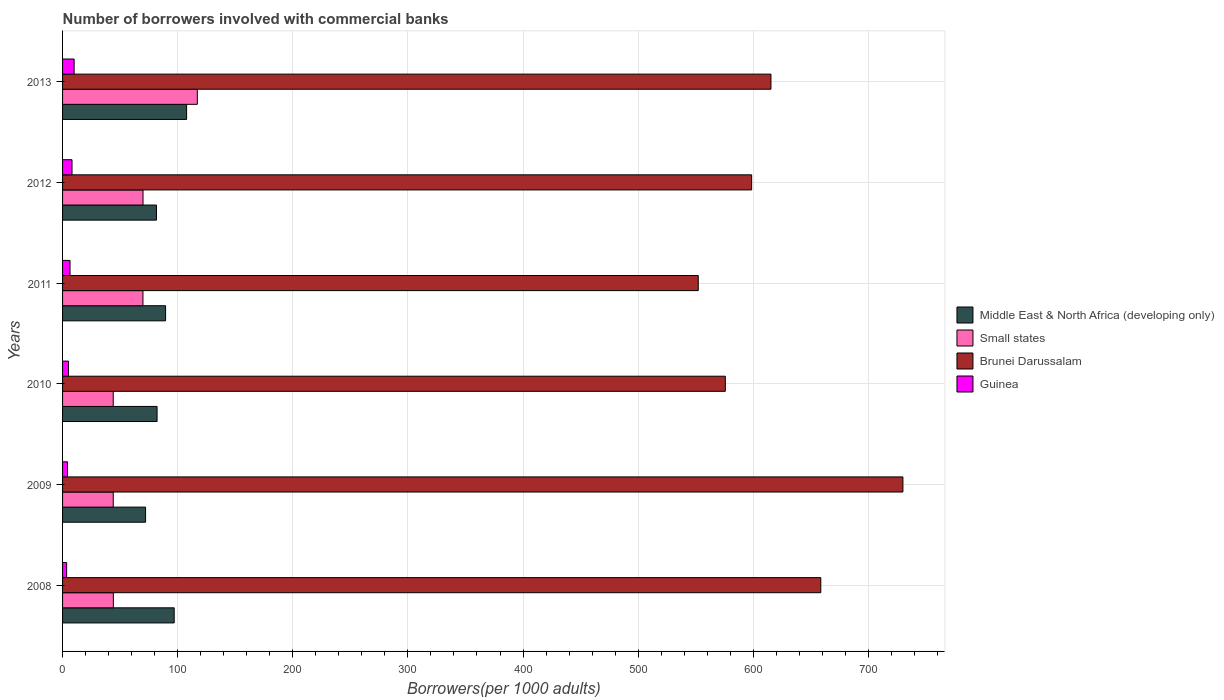How many different coloured bars are there?
Your answer should be compact. 4. How many bars are there on the 3rd tick from the top?
Your answer should be compact. 4. How many bars are there on the 6th tick from the bottom?
Ensure brevity in your answer.  4. What is the label of the 5th group of bars from the top?
Ensure brevity in your answer.  2009. In how many cases, is the number of bars for a given year not equal to the number of legend labels?
Keep it short and to the point. 0. What is the number of borrowers involved with commercial banks in Guinea in 2011?
Make the answer very short. 6.48. Across all years, what is the maximum number of borrowers involved with commercial banks in Middle East & North Africa (developing only)?
Your response must be concise. 107.75. Across all years, what is the minimum number of borrowers involved with commercial banks in Small states?
Offer a terse response. 44. In which year was the number of borrowers involved with commercial banks in Middle East & North Africa (developing only) minimum?
Your response must be concise. 2009. What is the total number of borrowers involved with commercial banks in Guinea in the graph?
Keep it short and to the point. 37.73. What is the difference between the number of borrowers involved with commercial banks in Guinea in 2008 and that in 2013?
Give a very brief answer. -6.51. What is the difference between the number of borrowers involved with commercial banks in Brunei Darussalam in 2008 and the number of borrowers involved with commercial banks in Middle East & North Africa (developing only) in 2013?
Offer a very short reply. 550.92. What is the average number of borrowers involved with commercial banks in Brunei Darussalam per year?
Give a very brief answer. 621.77. In the year 2010, what is the difference between the number of borrowers involved with commercial banks in Brunei Darussalam and number of borrowers involved with commercial banks in Small states?
Make the answer very short. 531.73. What is the ratio of the number of borrowers involved with commercial banks in Middle East & North Africa (developing only) in 2010 to that in 2013?
Your answer should be compact. 0.76. Is the difference between the number of borrowers involved with commercial banks in Brunei Darussalam in 2008 and 2011 greater than the difference between the number of borrowers involved with commercial banks in Small states in 2008 and 2011?
Provide a short and direct response. Yes. What is the difference between the highest and the second highest number of borrowers involved with commercial banks in Small states?
Provide a succinct answer. 47.18. What is the difference between the highest and the lowest number of borrowers involved with commercial banks in Brunei Darussalam?
Your response must be concise. 177.78. Is the sum of the number of borrowers involved with commercial banks in Middle East & North Africa (developing only) in 2012 and 2013 greater than the maximum number of borrowers involved with commercial banks in Small states across all years?
Provide a short and direct response. Yes. Is it the case that in every year, the sum of the number of borrowers involved with commercial banks in Small states and number of borrowers involved with commercial banks in Brunei Darussalam is greater than the sum of number of borrowers involved with commercial banks in Middle East & North Africa (developing only) and number of borrowers involved with commercial banks in Guinea?
Keep it short and to the point. Yes. What does the 1st bar from the top in 2009 represents?
Offer a very short reply. Guinea. What does the 4th bar from the bottom in 2010 represents?
Provide a succinct answer. Guinea. Are all the bars in the graph horizontal?
Provide a short and direct response. Yes. Are the values on the major ticks of X-axis written in scientific E-notation?
Provide a succinct answer. No. How many legend labels are there?
Offer a terse response. 4. What is the title of the graph?
Make the answer very short. Number of borrowers involved with commercial banks. Does "Sub-Saharan Africa (all income levels)" appear as one of the legend labels in the graph?
Give a very brief answer. No. What is the label or title of the X-axis?
Ensure brevity in your answer.  Borrowers(per 1000 adults). What is the label or title of the Y-axis?
Give a very brief answer. Years. What is the Borrowers(per 1000 adults) in Middle East & North Africa (developing only) in 2008?
Offer a very short reply. 96.96. What is the Borrowers(per 1000 adults) of Small states in 2008?
Give a very brief answer. 44.11. What is the Borrowers(per 1000 adults) in Brunei Darussalam in 2008?
Give a very brief answer. 658.67. What is the Borrowers(per 1000 adults) in Guinea in 2008?
Provide a succinct answer. 3.54. What is the Borrowers(per 1000 adults) of Middle East & North Africa (developing only) in 2009?
Your answer should be compact. 72.11. What is the Borrowers(per 1000 adults) in Small states in 2009?
Give a very brief answer. 44.03. What is the Borrowers(per 1000 adults) of Brunei Darussalam in 2009?
Provide a succinct answer. 730.02. What is the Borrowers(per 1000 adults) in Guinea in 2009?
Your response must be concise. 4.3. What is the Borrowers(per 1000 adults) in Middle East & North Africa (developing only) in 2010?
Your answer should be compact. 82.1. What is the Borrowers(per 1000 adults) of Small states in 2010?
Provide a short and direct response. 44. What is the Borrowers(per 1000 adults) in Brunei Darussalam in 2010?
Offer a terse response. 575.73. What is the Borrowers(per 1000 adults) of Guinea in 2010?
Your answer should be compact. 5.16. What is the Borrowers(per 1000 adults) of Middle East & North Africa (developing only) in 2011?
Offer a very short reply. 89.5. What is the Borrowers(per 1000 adults) of Small states in 2011?
Make the answer very short. 69.83. What is the Borrowers(per 1000 adults) in Brunei Darussalam in 2011?
Make the answer very short. 552.23. What is the Borrowers(per 1000 adults) in Guinea in 2011?
Offer a very short reply. 6.48. What is the Borrowers(per 1000 adults) of Middle East & North Africa (developing only) in 2012?
Your answer should be very brief. 81.61. What is the Borrowers(per 1000 adults) of Small states in 2012?
Your answer should be compact. 69.88. What is the Borrowers(per 1000 adults) of Brunei Darussalam in 2012?
Your answer should be very brief. 598.59. What is the Borrowers(per 1000 adults) in Guinea in 2012?
Offer a very short reply. 8.2. What is the Borrowers(per 1000 adults) of Middle East & North Africa (developing only) in 2013?
Offer a very short reply. 107.75. What is the Borrowers(per 1000 adults) of Small states in 2013?
Offer a very short reply. 117.06. What is the Borrowers(per 1000 adults) of Brunei Darussalam in 2013?
Your response must be concise. 615.37. What is the Borrowers(per 1000 adults) in Guinea in 2013?
Offer a very short reply. 10.05. Across all years, what is the maximum Borrowers(per 1000 adults) in Middle East & North Africa (developing only)?
Ensure brevity in your answer.  107.75. Across all years, what is the maximum Borrowers(per 1000 adults) of Small states?
Give a very brief answer. 117.06. Across all years, what is the maximum Borrowers(per 1000 adults) of Brunei Darussalam?
Provide a short and direct response. 730.02. Across all years, what is the maximum Borrowers(per 1000 adults) in Guinea?
Your response must be concise. 10.05. Across all years, what is the minimum Borrowers(per 1000 adults) in Middle East & North Africa (developing only)?
Give a very brief answer. 72.11. Across all years, what is the minimum Borrowers(per 1000 adults) of Small states?
Your response must be concise. 44. Across all years, what is the minimum Borrowers(per 1000 adults) in Brunei Darussalam?
Make the answer very short. 552.23. Across all years, what is the minimum Borrowers(per 1000 adults) of Guinea?
Offer a terse response. 3.54. What is the total Borrowers(per 1000 adults) in Middle East & North Africa (developing only) in the graph?
Offer a very short reply. 530.03. What is the total Borrowers(per 1000 adults) in Small states in the graph?
Make the answer very short. 388.91. What is the total Borrowers(per 1000 adults) in Brunei Darussalam in the graph?
Offer a very short reply. 3730.61. What is the total Borrowers(per 1000 adults) in Guinea in the graph?
Ensure brevity in your answer.  37.73. What is the difference between the Borrowers(per 1000 adults) in Middle East & North Africa (developing only) in 2008 and that in 2009?
Your answer should be compact. 24.86. What is the difference between the Borrowers(per 1000 adults) in Small states in 2008 and that in 2009?
Keep it short and to the point. 0.08. What is the difference between the Borrowers(per 1000 adults) of Brunei Darussalam in 2008 and that in 2009?
Your answer should be very brief. -71.35. What is the difference between the Borrowers(per 1000 adults) of Guinea in 2008 and that in 2009?
Your response must be concise. -0.76. What is the difference between the Borrowers(per 1000 adults) in Middle East & North Africa (developing only) in 2008 and that in 2010?
Offer a terse response. 14.86. What is the difference between the Borrowers(per 1000 adults) in Small states in 2008 and that in 2010?
Make the answer very short. 0.1. What is the difference between the Borrowers(per 1000 adults) in Brunei Darussalam in 2008 and that in 2010?
Your response must be concise. 82.93. What is the difference between the Borrowers(per 1000 adults) in Guinea in 2008 and that in 2010?
Provide a short and direct response. -1.63. What is the difference between the Borrowers(per 1000 adults) of Middle East & North Africa (developing only) in 2008 and that in 2011?
Give a very brief answer. 7.46. What is the difference between the Borrowers(per 1000 adults) of Small states in 2008 and that in 2011?
Provide a short and direct response. -25.73. What is the difference between the Borrowers(per 1000 adults) in Brunei Darussalam in 2008 and that in 2011?
Your answer should be compact. 106.43. What is the difference between the Borrowers(per 1000 adults) of Guinea in 2008 and that in 2011?
Ensure brevity in your answer.  -2.94. What is the difference between the Borrowers(per 1000 adults) in Middle East & North Africa (developing only) in 2008 and that in 2012?
Offer a terse response. 15.36. What is the difference between the Borrowers(per 1000 adults) of Small states in 2008 and that in 2012?
Ensure brevity in your answer.  -25.78. What is the difference between the Borrowers(per 1000 adults) of Brunei Darussalam in 2008 and that in 2012?
Your response must be concise. 60.08. What is the difference between the Borrowers(per 1000 adults) in Guinea in 2008 and that in 2012?
Offer a very short reply. -4.67. What is the difference between the Borrowers(per 1000 adults) of Middle East & North Africa (developing only) in 2008 and that in 2013?
Ensure brevity in your answer.  -10.79. What is the difference between the Borrowers(per 1000 adults) in Small states in 2008 and that in 2013?
Offer a terse response. -72.96. What is the difference between the Borrowers(per 1000 adults) of Brunei Darussalam in 2008 and that in 2013?
Make the answer very short. 43.29. What is the difference between the Borrowers(per 1000 adults) in Guinea in 2008 and that in 2013?
Give a very brief answer. -6.51. What is the difference between the Borrowers(per 1000 adults) of Middle East & North Africa (developing only) in 2009 and that in 2010?
Your answer should be very brief. -10. What is the difference between the Borrowers(per 1000 adults) in Small states in 2009 and that in 2010?
Give a very brief answer. 0.03. What is the difference between the Borrowers(per 1000 adults) of Brunei Darussalam in 2009 and that in 2010?
Give a very brief answer. 154.28. What is the difference between the Borrowers(per 1000 adults) of Guinea in 2009 and that in 2010?
Give a very brief answer. -0.87. What is the difference between the Borrowers(per 1000 adults) in Middle East & North Africa (developing only) in 2009 and that in 2011?
Your answer should be compact. -17.4. What is the difference between the Borrowers(per 1000 adults) in Small states in 2009 and that in 2011?
Provide a succinct answer. -25.8. What is the difference between the Borrowers(per 1000 adults) in Brunei Darussalam in 2009 and that in 2011?
Provide a short and direct response. 177.78. What is the difference between the Borrowers(per 1000 adults) in Guinea in 2009 and that in 2011?
Your answer should be very brief. -2.19. What is the difference between the Borrowers(per 1000 adults) of Middle East & North Africa (developing only) in 2009 and that in 2012?
Your answer should be very brief. -9.5. What is the difference between the Borrowers(per 1000 adults) of Small states in 2009 and that in 2012?
Give a very brief answer. -25.85. What is the difference between the Borrowers(per 1000 adults) of Brunei Darussalam in 2009 and that in 2012?
Ensure brevity in your answer.  131.43. What is the difference between the Borrowers(per 1000 adults) of Guinea in 2009 and that in 2012?
Offer a very short reply. -3.91. What is the difference between the Borrowers(per 1000 adults) of Middle East & North Africa (developing only) in 2009 and that in 2013?
Your response must be concise. -35.65. What is the difference between the Borrowers(per 1000 adults) of Small states in 2009 and that in 2013?
Your answer should be compact. -73.03. What is the difference between the Borrowers(per 1000 adults) in Brunei Darussalam in 2009 and that in 2013?
Make the answer very short. 114.64. What is the difference between the Borrowers(per 1000 adults) of Guinea in 2009 and that in 2013?
Ensure brevity in your answer.  -5.75. What is the difference between the Borrowers(per 1000 adults) in Middle East & North Africa (developing only) in 2010 and that in 2011?
Make the answer very short. -7.4. What is the difference between the Borrowers(per 1000 adults) of Small states in 2010 and that in 2011?
Provide a succinct answer. -25.83. What is the difference between the Borrowers(per 1000 adults) in Brunei Darussalam in 2010 and that in 2011?
Provide a short and direct response. 23.5. What is the difference between the Borrowers(per 1000 adults) of Guinea in 2010 and that in 2011?
Your answer should be compact. -1.32. What is the difference between the Borrowers(per 1000 adults) of Middle East & North Africa (developing only) in 2010 and that in 2012?
Your answer should be compact. 0.5. What is the difference between the Borrowers(per 1000 adults) of Small states in 2010 and that in 2012?
Make the answer very short. -25.88. What is the difference between the Borrowers(per 1000 adults) of Brunei Darussalam in 2010 and that in 2012?
Provide a short and direct response. -22.86. What is the difference between the Borrowers(per 1000 adults) in Guinea in 2010 and that in 2012?
Make the answer very short. -3.04. What is the difference between the Borrowers(per 1000 adults) in Middle East & North Africa (developing only) in 2010 and that in 2013?
Offer a very short reply. -25.65. What is the difference between the Borrowers(per 1000 adults) in Small states in 2010 and that in 2013?
Give a very brief answer. -73.06. What is the difference between the Borrowers(per 1000 adults) in Brunei Darussalam in 2010 and that in 2013?
Offer a terse response. -39.64. What is the difference between the Borrowers(per 1000 adults) in Guinea in 2010 and that in 2013?
Ensure brevity in your answer.  -4.88. What is the difference between the Borrowers(per 1000 adults) in Middle East & North Africa (developing only) in 2011 and that in 2012?
Offer a terse response. 7.9. What is the difference between the Borrowers(per 1000 adults) of Small states in 2011 and that in 2012?
Offer a terse response. -0.05. What is the difference between the Borrowers(per 1000 adults) in Brunei Darussalam in 2011 and that in 2012?
Your answer should be compact. -46.36. What is the difference between the Borrowers(per 1000 adults) of Guinea in 2011 and that in 2012?
Offer a very short reply. -1.72. What is the difference between the Borrowers(per 1000 adults) of Middle East & North Africa (developing only) in 2011 and that in 2013?
Your answer should be very brief. -18.25. What is the difference between the Borrowers(per 1000 adults) in Small states in 2011 and that in 2013?
Your response must be concise. -47.23. What is the difference between the Borrowers(per 1000 adults) in Brunei Darussalam in 2011 and that in 2013?
Offer a terse response. -63.14. What is the difference between the Borrowers(per 1000 adults) of Guinea in 2011 and that in 2013?
Make the answer very short. -3.56. What is the difference between the Borrowers(per 1000 adults) in Middle East & North Africa (developing only) in 2012 and that in 2013?
Offer a very short reply. -26.15. What is the difference between the Borrowers(per 1000 adults) in Small states in 2012 and that in 2013?
Offer a terse response. -47.18. What is the difference between the Borrowers(per 1000 adults) in Brunei Darussalam in 2012 and that in 2013?
Make the answer very short. -16.78. What is the difference between the Borrowers(per 1000 adults) of Guinea in 2012 and that in 2013?
Offer a terse response. -1.84. What is the difference between the Borrowers(per 1000 adults) in Middle East & North Africa (developing only) in 2008 and the Borrowers(per 1000 adults) in Small states in 2009?
Offer a terse response. 52.93. What is the difference between the Borrowers(per 1000 adults) of Middle East & North Africa (developing only) in 2008 and the Borrowers(per 1000 adults) of Brunei Darussalam in 2009?
Offer a very short reply. -633.05. What is the difference between the Borrowers(per 1000 adults) of Middle East & North Africa (developing only) in 2008 and the Borrowers(per 1000 adults) of Guinea in 2009?
Provide a short and direct response. 92.67. What is the difference between the Borrowers(per 1000 adults) of Small states in 2008 and the Borrowers(per 1000 adults) of Brunei Darussalam in 2009?
Provide a short and direct response. -685.91. What is the difference between the Borrowers(per 1000 adults) in Small states in 2008 and the Borrowers(per 1000 adults) in Guinea in 2009?
Provide a short and direct response. 39.81. What is the difference between the Borrowers(per 1000 adults) in Brunei Darussalam in 2008 and the Borrowers(per 1000 adults) in Guinea in 2009?
Provide a succinct answer. 654.37. What is the difference between the Borrowers(per 1000 adults) of Middle East & North Africa (developing only) in 2008 and the Borrowers(per 1000 adults) of Small states in 2010?
Offer a terse response. 52.96. What is the difference between the Borrowers(per 1000 adults) in Middle East & North Africa (developing only) in 2008 and the Borrowers(per 1000 adults) in Brunei Darussalam in 2010?
Offer a very short reply. -478.77. What is the difference between the Borrowers(per 1000 adults) of Middle East & North Africa (developing only) in 2008 and the Borrowers(per 1000 adults) of Guinea in 2010?
Your answer should be very brief. 91.8. What is the difference between the Borrowers(per 1000 adults) of Small states in 2008 and the Borrowers(per 1000 adults) of Brunei Darussalam in 2010?
Make the answer very short. -531.63. What is the difference between the Borrowers(per 1000 adults) in Small states in 2008 and the Borrowers(per 1000 adults) in Guinea in 2010?
Keep it short and to the point. 38.94. What is the difference between the Borrowers(per 1000 adults) of Brunei Darussalam in 2008 and the Borrowers(per 1000 adults) of Guinea in 2010?
Provide a short and direct response. 653.5. What is the difference between the Borrowers(per 1000 adults) in Middle East & North Africa (developing only) in 2008 and the Borrowers(per 1000 adults) in Small states in 2011?
Keep it short and to the point. 27.13. What is the difference between the Borrowers(per 1000 adults) of Middle East & North Africa (developing only) in 2008 and the Borrowers(per 1000 adults) of Brunei Darussalam in 2011?
Offer a terse response. -455.27. What is the difference between the Borrowers(per 1000 adults) of Middle East & North Africa (developing only) in 2008 and the Borrowers(per 1000 adults) of Guinea in 2011?
Give a very brief answer. 90.48. What is the difference between the Borrowers(per 1000 adults) of Small states in 2008 and the Borrowers(per 1000 adults) of Brunei Darussalam in 2011?
Offer a very short reply. -508.13. What is the difference between the Borrowers(per 1000 adults) in Small states in 2008 and the Borrowers(per 1000 adults) in Guinea in 2011?
Give a very brief answer. 37.62. What is the difference between the Borrowers(per 1000 adults) in Brunei Darussalam in 2008 and the Borrowers(per 1000 adults) in Guinea in 2011?
Provide a short and direct response. 652.18. What is the difference between the Borrowers(per 1000 adults) of Middle East & North Africa (developing only) in 2008 and the Borrowers(per 1000 adults) of Small states in 2012?
Offer a terse response. 27.08. What is the difference between the Borrowers(per 1000 adults) of Middle East & North Africa (developing only) in 2008 and the Borrowers(per 1000 adults) of Brunei Darussalam in 2012?
Provide a short and direct response. -501.63. What is the difference between the Borrowers(per 1000 adults) of Middle East & North Africa (developing only) in 2008 and the Borrowers(per 1000 adults) of Guinea in 2012?
Keep it short and to the point. 88.76. What is the difference between the Borrowers(per 1000 adults) in Small states in 2008 and the Borrowers(per 1000 adults) in Brunei Darussalam in 2012?
Your answer should be compact. -554.48. What is the difference between the Borrowers(per 1000 adults) of Small states in 2008 and the Borrowers(per 1000 adults) of Guinea in 2012?
Your answer should be compact. 35.9. What is the difference between the Borrowers(per 1000 adults) in Brunei Darussalam in 2008 and the Borrowers(per 1000 adults) in Guinea in 2012?
Your answer should be very brief. 650.46. What is the difference between the Borrowers(per 1000 adults) of Middle East & North Africa (developing only) in 2008 and the Borrowers(per 1000 adults) of Small states in 2013?
Ensure brevity in your answer.  -20.1. What is the difference between the Borrowers(per 1000 adults) of Middle East & North Africa (developing only) in 2008 and the Borrowers(per 1000 adults) of Brunei Darussalam in 2013?
Provide a succinct answer. -518.41. What is the difference between the Borrowers(per 1000 adults) of Middle East & North Africa (developing only) in 2008 and the Borrowers(per 1000 adults) of Guinea in 2013?
Your answer should be very brief. 86.92. What is the difference between the Borrowers(per 1000 adults) of Small states in 2008 and the Borrowers(per 1000 adults) of Brunei Darussalam in 2013?
Provide a succinct answer. -571.27. What is the difference between the Borrowers(per 1000 adults) in Small states in 2008 and the Borrowers(per 1000 adults) in Guinea in 2013?
Your answer should be very brief. 34.06. What is the difference between the Borrowers(per 1000 adults) of Brunei Darussalam in 2008 and the Borrowers(per 1000 adults) of Guinea in 2013?
Offer a very short reply. 648.62. What is the difference between the Borrowers(per 1000 adults) in Middle East & North Africa (developing only) in 2009 and the Borrowers(per 1000 adults) in Small states in 2010?
Offer a very short reply. 28.1. What is the difference between the Borrowers(per 1000 adults) of Middle East & North Africa (developing only) in 2009 and the Borrowers(per 1000 adults) of Brunei Darussalam in 2010?
Make the answer very short. -503.63. What is the difference between the Borrowers(per 1000 adults) in Middle East & North Africa (developing only) in 2009 and the Borrowers(per 1000 adults) in Guinea in 2010?
Offer a very short reply. 66.94. What is the difference between the Borrowers(per 1000 adults) of Small states in 2009 and the Borrowers(per 1000 adults) of Brunei Darussalam in 2010?
Your answer should be compact. -531.7. What is the difference between the Borrowers(per 1000 adults) of Small states in 2009 and the Borrowers(per 1000 adults) of Guinea in 2010?
Provide a short and direct response. 38.87. What is the difference between the Borrowers(per 1000 adults) of Brunei Darussalam in 2009 and the Borrowers(per 1000 adults) of Guinea in 2010?
Keep it short and to the point. 724.85. What is the difference between the Borrowers(per 1000 adults) of Middle East & North Africa (developing only) in 2009 and the Borrowers(per 1000 adults) of Small states in 2011?
Keep it short and to the point. 2.27. What is the difference between the Borrowers(per 1000 adults) in Middle East & North Africa (developing only) in 2009 and the Borrowers(per 1000 adults) in Brunei Darussalam in 2011?
Your answer should be very brief. -480.13. What is the difference between the Borrowers(per 1000 adults) of Middle East & North Africa (developing only) in 2009 and the Borrowers(per 1000 adults) of Guinea in 2011?
Offer a terse response. 65.62. What is the difference between the Borrowers(per 1000 adults) in Small states in 2009 and the Borrowers(per 1000 adults) in Brunei Darussalam in 2011?
Give a very brief answer. -508.2. What is the difference between the Borrowers(per 1000 adults) of Small states in 2009 and the Borrowers(per 1000 adults) of Guinea in 2011?
Your response must be concise. 37.55. What is the difference between the Borrowers(per 1000 adults) in Brunei Darussalam in 2009 and the Borrowers(per 1000 adults) in Guinea in 2011?
Your answer should be very brief. 723.53. What is the difference between the Borrowers(per 1000 adults) in Middle East & North Africa (developing only) in 2009 and the Borrowers(per 1000 adults) in Small states in 2012?
Make the answer very short. 2.22. What is the difference between the Borrowers(per 1000 adults) of Middle East & North Africa (developing only) in 2009 and the Borrowers(per 1000 adults) of Brunei Darussalam in 2012?
Your answer should be compact. -526.48. What is the difference between the Borrowers(per 1000 adults) of Middle East & North Africa (developing only) in 2009 and the Borrowers(per 1000 adults) of Guinea in 2012?
Offer a terse response. 63.9. What is the difference between the Borrowers(per 1000 adults) of Small states in 2009 and the Borrowers(per 1000 adults) of Brunei Darussalam in 2012?
Provide a short and direct response. -554.56. What is the difference between the Borrowers(per 1000 adults) of Small states in 2009 and the Borrowers(per 1000 adults) of Guinea in 2012?
Your answer should be compact. 35.83. What is the difference between the Borrowers(per 1000 adults) of Brunei Darussalam in 2009 and the Borrowers(per 1000 adults) of Guinea in 2012?
Offer a terse response. 721.81. What is the difference between the Borrowers(per 1000 adults) in Middle East & North Africa (developing only) in 2009 and the Borrowers(per 1000 adults) in Small states in 2013?
Make the answer very short. -44.95. What is the difference between the Borrowers(per 1000 adults) in Middle East & North Africa (developing only) in 2009 and the Borrowers(per 1000 adults) in Brunei Darussalam in 2013?
Provide a short and direct response. -543.27. What is the difference between the Borrowers(per 1000 adults) in Middle East & North Africa (developing only) in 2009 and the Borrowers(per 1000 adults) in Guinea in 2013?
Make the answer very short. 62.06. What is the difference between the Borrowers(per 1000 adults) of Small states in 2009 and the Borrowers(per 1000 adults) of Brunei Darussalam in 2013?
Make the answer very short. -571.34. What is the difference between the Borrowers(per 1000 adults) of Small states in 2009 and the Borrowers(per 1000 adults) of Guinea in 2013?
Provide a short and direct response. 33.98. What is the difference between the Borrowers(per 1000 adults) of Brunei Darussalam in 2009 and the Borrowers(per 1000 adults) of Guinea in 2013?
Provide a succinct answer. 719.97. What is the difference between the Borrowers(per 1000 adults) in Middle East & North Africa (developing only) in 2010 and the Borrowers(per 1000 adults) in Small states in 2011?
Your answer should be compact. 12.27. What is the difference between the Borrowers(per 1000 adults) of Middle East & North Africa (developing only) in 2010 and the Borrowers(per 1000 adults) of Brunei Darussalam in 2011?
Offer a very short reply. -470.13. What is the difference between the Borrowers(per 1000 adults) of Middle East & North Africa (developing only) in 2010 and the Borrowers(per 1000 adults) of Guinea in 2011?
Ensure brevity in your answer.  75.62. What is the difference between the Borrowers(per 1000 adults) in Small states in 2010 and the Borrowers(per 1000 adults) in Brunei Darussalam in 2011?
Your response must be concise. -508.23. What is the difference between the Borrowers(per 1000 adults) in Small states in 2010 and the Borrowers(per 1000 adults) in Guinea in 2011?
Ensure brevity in your answer.  37.52. What is the difference between the Borrowers(per 1000 adults) of Brunei Darussalam in 2010 and the Borrowers(per 1000 adults) of Guinea in 2011?
Give a very brief answer. 569.25. What is the difference between the Borrowers(per 1000 adults) of Middle East & North Africa (developing only) in 2010 and the Borrowers(per 1000 adults) of Small states in 2012?
Give a very brief answer. 12.22. What is the difference between the Borrowers(per 1000 adults) in Middle East & North Africa (developing only) in 2010 and the Borrowers(per 1000 adults) in Brunei Darussalam in 2012?
Your answer should be compact. -516.49. What is the difference between the Borrowers(per 1000 adults) in Middle East & North Africa (developing only) in 2010 and the Borrowers(per 1000 adults) in Guinea in 2012?
Offer a very short reply. 73.9. What is the difference between the Borrowers(per 1000 adults) in Small states in 2010 and the Borrowers(per 1000 adults) in Brunei Darussalam in 2012?
Provide a succinct answer. -554.59. What is the difference between the Borrowers(per 1000 adults) of Small states in 2010 and the Borrowers(per 1000 adults) of Guinea in 2012?
Make the answer very short. 35.8. What is the difference between the Borrowers(per 1000 adults) of Brunei Darussalam in 2010 and the Borrowers(per 1000 adults) of Guinea in 2012?
Offer a terse response. 567.53. What is the difference between the Borrowers(per 1000 adults) in Middle East & North Africa (developing only) in 2010 and the Borrowers(per 1000 adults) in Small states in 2013?
Provide a succinct answer. -34.96. What is the difference between the Borrowers(per 1000 adults) in Middle East & North Africa (developing only) in 2010 and the Borrowers(per 1000 adults) in Brunei Darussalam in 2013?
Your answer should be very brief. -533.27. What is the difference between the Borrowers(per 1000 adults) of Middle East & North Africa (developing only) in 2010 and the Borrowers(per 1000 adults) of Guinea in 2013?
Your answer should be very brief. 72.06. What is the difference between the Borrowers(per 1000 adults) in Small states in 2010 and the Borrowers(per 1000 adults) in Brunei Darussalam in 2013?
Make the answer very short. -571.37. What is the difference between the Borrowers(per 1000 adults) in Small states in 2010 and the Borrowers(per 1000 adults) in Guinea in 2013?
Give a very brief answer. 33.96. What is the difference between the Borrowers(per 1000 adults) in Brunei Darussalam in 2010 and the Borrowers(per 1000 adults) in Guinea in 2013?
Your response must be concise. 565.69. What is the difference between the Borrowers(per 1000 adults) of Middle East & North Africa (developing only) in 2011 and the Borrowers(per 1000 adults) of Small states in 2012?
Ensure brevity in your answer.  19.62. What is the difference between the Borrowers(per 1000 adults) in Middle East & North Africa (developing only) in 2011 and the Borrowers(per 1000 adults) in Brunei Darussalam in 2012?
Ensure brevity in your answer.  -509.09. What is the difference between the Borrowers(per 1000 adults) in Middle East & North Africa (developing only) in 2011 and the Borrowers(per 1000 adults) in Guinea in 2012?
Offer a very short reply. 81.3. What is the difference between the Borrowers(per 1000 adults) of Small states in 2011 and the Borrowers(per 1000 adults) of Brunei Darussalam in 2012?
Provide a short and direct response. -528.76. What is the difference between the Borrowers(per 1000 adults) of Small states in 2011 and the Borrowers(per 1000 adults) of Guinea in 2012?
Your response must be concise. 61.63. What is the difference between the Borrowers(per 1000 adults) of Brunei Darussalam in 2011 and the Borrowers(per 1000 adults) of Guinea in 2012?
Keep it short and to the point. 544.03. What is the difference between the Borrowers(per 1000 adults) in Middle East & North Africa (developing only) in 2011 and the Borrowers(per 1000 adults) in Small states in 2013?
Ensure brevity in your answer.  -27.56. What is the difference between the Borrowers(per 1000 adults) of Middle East & North Africa (developing only) in 2011 and the Borrowers(per 1000 adults) of Brunei Darussalam in 2013?
Your answer should be compact. -525.87. What is the difference between the Borrowers(per 1000 adults) in Middle East & North Africa (developing only) in 2011 and the Borrowers(per 1000 adults) in Guinea in 2013?
Provide a succinct answer. 79.46. What is the difference between the Borrowers(per 1000 adults) of Small states in 2011 and the Borrowers(per 1000 adults) of Brunei Darussalam in 2013?
Your answer should be compact. -545.54. What is the difference between the Borrowers(per 1000 adults) of Small states in 2011 and the Borrowers(per 1000 adults) of Guinea in 2013?
Provide a succinct answer. 59.79. What is the difference between the Borrowers(per 1000 adults) of Brunei Darussalam in 2011 and the Borrowers(per 1000 adults) of Guinea in 2013?
Provide a short and direct response. 542.19. What is the difference between the Borrowers(per 1000 adults) of Middle East & North Africa (developing only) in 2012 and the Borrowers(per 1000 adults) of Small states in 2013?
Give a very brief answer. -35.45. What is the difference between the Borrowers(per 1000 adults) of Middle East & North Africa (developing only) in 2012 and the Borrowers(per 1000 adults) of Brunei Darussalam in 2013?
Ensure brevity in your answer.  -533.77. What is the difference between the Borrowers(per 1000 adults) of Middle East & North Africa (developing only) in 2012 and the Borrowers(per 1000 adults) of Guinea in 2013?
Offer a terse response. 71.56. What is the difference between the Borrowers(per 1000 adults) of Small states in 2012 and the Borrowers(per 1000 adults) of Brunei Darussalam in 2013?
Keep it short and to the point. -545.49. What is the difference between the Borrowers(per 1000 adults) in Small states in 2012 and the Borrowers(per 1000 adults) in Guinea in 2013?
Provide a short and direct response. 59.84. What is the difference between the Borrowers(per 1000 adults) of Brunei Darussalam in 2012 and the Borrowers(per 1000 adults) of Guinea in 2013?
Make the answer very short. 588.54. What is the average Borrowers(per 1000 adults) in Middle East & North Africa (developing only) per year?
Ensure brevity in your answer.  88.34. What is the average Borrowers(per 1000 adults) in Small states per year?
Your response must be concise. 64.82. What is the average Borrowers(per 1000 adults) of Brunei Darussalam per year?
Make the answer very short. 621.77. What is the average Borrowers(per 1000 adults) in Guinea per year?
Offer a terse response. 6.29. In the year 2008, what is the difference between the Borrowers(per 1000 adults) in Middle East & North Africa (developing only) and Borrowers(per 1000 adults) in Small states?
Keep it short and to the point. 52.86. In the year 2008, what is the difference between the Borrowers(per 1000 adults) in Middle East & North Africa (developing only) and Borrowers(per 1000 adults) in Brunei Darussalam?
Offer a terse response. -561.7. In the year 2008, what is the difference between the Borrowers(per 1000 adults) of Middle East & North Africa (developing only) and Borrowers(per 1000 adults) of Guinea?
Offer a terse response. 93.42. In the year 2008, what is the difference between the Borrowers(per 1000 adults) in Small states and Borrowers(per 1000 adults) in Brunei Darussalam?
Offer a terse response. -614.56. In the year 2008, what is the difference between the Borrowers(per 1000 adults) in Small states and Borrowers(per 1000 adults) in Guinea?
Your response must be concise. 40.57. In the year 2008, what is the difference between the Borrowers(per 1000 adults) in Brunei Darussalam and Borrowers(per 1000 adults) in Guinea?
Offer a very short reply. 655.13. In the year 2009, what is the difference between the Borrowers(per 1000 adults) in Middle East & North Africa (developing only) and Borrowers(per 1000 adults) in Small states?
Your response must be concise. 28.08. In the year 2009, what is the difference between the Borrowers(per 1000 adults) in Middle East & North Africa (developing only) and Borrowers(per 1000 adults) in Brunei Darussalam?
Ensure brevity in your answer.  -657.91. In the year 2009, what is the difference between the Borrowers(per 1000 adults) in Middle East & North Africa (developing only) and Borrowers(per 1000 adults) in Guinea?
Provide a short and direct response. 67.81. In the year 2009, what is the difference between the Borrowers(per 1000 adults) in Small states and Borrowers(per 1000 adults) in Brunei Darussalam?
Your answer should be very brief. -685.99. In the year 2009, what is the difference between the Borrowers(per 1000 adults) of Small states and Borrowers(per 1000 adults) of Guinea?
Your answer should be compact. 39.73. In the year 2009, what is the difference between the Borrowers(per 1000 adults) of Brunei Darussalam and Borrowers(per 1000 adults) of Guinea?
Offer a terse response. 725.72. In the year 2010, what is the difference between the Borrowers(per 1000 adults) in Middle East & North Africa (developing only) and Borrowers(per 1000 adults) in Small states?
Make the answer very short. 38.1. In the year 2010, what is the difference between the Borrowers(per 1000 adults) of Middle East & North Africa (developing only) and Borrowers(per 1000 adults) of Brunei Darussalam?
Your answer should be compact. -493.63. In the year 2010, what is the difference between the Borrowers(per 1000 adults) of Middle East & North Africa (developing only) and Borrowers(per 1000 adults) of Guinea?
Your answer should be very brief. 76.94. In the year 2010, what is the difference between the Borrowers(per 1000 adults) of Small states and Borrowers(per 1000 adults) of Brunei Darussalam?
Make the answer very short. -531.73. In the year 2010, what is the difference between the Borrowers(per 1000 adults) of Small states and Borrowers(per 1000 adults) of Guinea?
Offer a very short reply. 38.84. In the year 2010, what is the difference between the Borrowers(per 1000 adults) of Brunei Darussalam and Borrowers(per 1000 adults) of Guinea?
Give a very brief answer. 570.57. In the year 2011, what is the difference between the Borrowers(per 1000 adults) of Middle East & North Africa (developing only) and Borrowers(per 1000 adults) of Small states?
Offer a terse response. 19.67. In the year 2011, what is the difference between the Borrowers(per 1000 adults) of Middle East & North Africa (developing only) and Borrowers(per 1000 adults) of Brunei Darussalam?
Offer a terse response. -462.73. In the year 2011, what is the difference between the Borrowers(per 1000 adults) of Middle East & North Africa (developing only) and Borrowers(per 1000 adults) of Guinea?
Offer a very short reply. 83.02. In the year 2011, what is the difference between the Borrowers(per 1000 adults) of Small states and Borrowers(per 1000 adults) of Brunei Darussalam?
Keep it short and to the point. -482.4. In the year 2011, what is the difference between the Borrowers(per 1000 adults) in Small states and Borrowers(per 1000 adults) in Guinea?
Your answer should be compact. 63.35. In the year 2011, what is the difference between the Borrowers(per 1000 adults) of Brunei Darussalam and Borrowers(per 1000 adults) of Guinea?
Provide a short and direct response. 545.75. In the year 2012, what is the difference between the Borrowers(per 1000 adults) of Middle East & North Africa (developing only) and Borrowers(per 1000 adults) of Small states?
Your response must be concise. 11.72. In the year 2012, what is the difference between the Borrowers(per 1000 adults) in Middle East & North Africa (developing only) and Borrowers(per 1000 adults) in Brunei Darussalam?
Offer a very short reply. -516.98. In the year 2012, what is the difference between the Borrowers(per 1000 adults) of Middle East & North Africa (developing only) and Borrowers(per 1000 adults) of Guinea?
Provide a succinct answer. 73.4. In the year 2012, what is the difference between the Borrowers(per 1000 adults) of Small states and Borrowers(per 1000 adults) of Brunei Darussalam?
Offer a terse response. -528.71. In the year 2012, what is the difference between the Borrowers(per 1000 adults) in Small states and Borrowers(per 1000 adults) in Guinea?
Your answer should be very brief. 61.68. In the year 2012, what is the difference between the Borrowers(per 1000 adults) of Brunei Darussalam and Borrowers(per 1000 adults) of Guinea?
Your answer should be compact. 590.38. In the year 2013, what is the difference between the Borrowers(per 1000 adults) of Middle East & North Africa (developing only) and Borrowers(per 1000 adults) of Small states?
Offer a terse response. -9.31. In the year 2013, what is the difference between the Borrowers(per 1000 adults) of Middle East & North Africa (developing only) and Borrowers(per 1000 adults) of Brunei Darussalam?
Your answer should be compact. -507.62. In the year 2013, what is the difference between the Borrowers(per 1000 adults) in Middle East & North Africa (developing only) and Borrowers(per 1000 adults) in Guinea?
Give a very brief answer. 97.71. In the year 2013, what is the difference between the Borrowers(per 1000 adults) of Small states and Borrowers(per 1000 adults) of Brunei Darussalam?
Provide a short and direct response. -498.31. In the year 2013, what is the difference between the Borrowers(per 1000 adults) in Small states and Borrowers(per 1000 adults) in Guinea?
Offer a terse response. 107.02. In the year 2013, what is the difference between the Borrowers(per 1000 adults) in Brunei Darussalam and Borrowers(per 1000 adults) in Guinea?
Offer a very short reply. 605.33. What is the ratio of the Borrowers(per 1000 adults) in Middle East & North Africa (developing only) in 2008 to that in 2009?
Ensure brevity in your answer.  1.34. What is the ratio of the Borrowers(per 1000 adults) of Small states in 2008 to that in 2009?
Give a very brief answer. 1. What is the ratio of the Borrowers(per 1000 adults) of Brunei Darussalam in 2008 to that in 2009?
Your answer should be very brief. 0.9. What is the ratio of the Borrowers(per 1000 adults) in Guinea in 2008 to that in 2009?
Provide a short and direct response. 0.82. What is the ratio of the Borrowers(per 1000 adults) of Middle East & North Africa (developing only) in 2008 to that in 2010?
Your answer should be very brief. 1.18. What is the ratio of the Borrowers(per 1000 adults) in Brunei Darussalam in 2008 to that in 2010?
Make the answer very short. 1.14. What is the ratio of the Borrowers(per 1000 adults) of Guinea in 2008 to that in 2010?
Offer a very short reply. 0.69. What is the ratio of the Borrowers(per 1000 adults) of Middle East & North Africa (developing only) in 2008 to that in 2011?
Your answer should be very brief. 1.08. What is the ratio of the Borrowers(per 1000 adults) in Small states in 2008 to that in 2011?
Provide a short and direct response. 0.63. What is the ratio of the Borrowers(per 1000 adults) of Brunei Darussalam in 2008 to that in 2011?
Ensure brevity in your answer.  1.19. What is the ratio of the Borrowers(per 1000 adults) in Guinea in 2008 to that in 2011?
Provide a succinct answer. 0.55. What is the ratio of the Borrowers(per 1000 adults) in Middle East & North Africa (developing only) in 2008 to that in 2012?
Your response must be concise. 1.19. What is the ratio of the Borrowers(per 1000 adults) in Small states in 2008 to that in 2012?
Your answer should be compact. 0.63. What is the ratio of the Borrowers(per 1000 adults) in Brunei Darussalam in 2008 to that in 2012?
Your answer should be compact. 1.1. What is the ratio of the Borrowers(per 1000 adults) in Guinea in 2008 to that in 2012?
Your response must be concise. 0.43. What is the ratio of the Borrowers(per 1000 adults) in Middle East & North Africa (developing only) in 2008 to that in 2013?
Make the answer very short. 0.9. What is the ratio of the Borrowers(per 1000 adults) in Small states in 2008 to that in 2013?
Ensure brevity in your answer.  0.38. What is the ratio of the Borrowers(per 1000 adults) of Brunei Darussalam in 2008 to that in 2013?
Offer a terse response. 1.07. What is the ratio of the Borrowers(per 1000 adults) in Guinea in 2008 to that in 2013?
Offer a very short reply. 0.35. What is the ratio of the Borrowers(per 1000 adults) in Middle East & North Africa (developing only) in 2009 to that in 2010?
Give a very brief answer. 0.88. What is the ratio of the Borrowers(per 1000 adults) in Small states in 2009 to that in 2010?
Give a very brief answer. 1. What is the ratio of the Borrowers(per 1000 adults) in Brunei Darussalam in 2009 to that in 2010?
Your answer should be very brief. 1.27. What is the ratio of the Borrowers(per 1000 adults) in Guinea in 2009 to that in 2010?
Your answer should be compact. 0.83. What is the ratio of the Borrowers(per 1000 adults) in Middle East & North Africa (developing only) in 2009 to that in 2011?
Give a very brief answer. 0.81. What is the ratio of the Borrowers(per 1000 adults) of Small states in 2009 to that in 2011?
Give a very brief answer. 0.63. What is the ratio of the Borrowers(per 1000 adults) of Brunei Darussalam in 2009 to that in 2011?
Make the answer very short. 1.32. What is the ratio of the Borrowers(per 1000 adults) in Guinea in 2009 to that in 2011?
Your response must be concise. 0.66. What is the ratio of the Borrowers(per 1000 adults) in Middle East & North Africa (developing only) in 2009 to that in 2012?
Provide a short and direct response. 0.88. What is the ratio of the Borrowers(per 1000 adults) of Small states in 2009 to that in 2012?
Offer a very short reply. 0.63. What is the ratio of the Borrowers(per 1000 adults) in Brunei Darussalam in 2009 to that in 2012?
Your answer should be compact. 1.22. What is the ratio of the Borrowers(per 1000 adults) of Guinea in 2009 to that in 2012?
Keep it short and to the point. 0.52. What is the ratio of the Borrowers(per 1000 adults) in Middle East & North Africa (developing only) in 2009 to that in 2013?
Your answer should be very brief. 0.67. What is the ratio of the Borrowers(per 1000 adults) in Small states in 2009 to that in 2013?
Keep it short and to the point. 0.38. What is the ratio of the Borrowers(per 1000 adults) of Brunei Darussalam in 2009 to that in 2013?
Your answer should be compact. 1.19. What is the ratio of the Borrowers(per 1000 adults) in Guinea in 2009 to that in 2013?
Offer a very short reply. 0.43. What is the ratio of the Borrowers(per 1000 adults) of Middle East & North Africa (developing only) in 2010 to that in 2011?
Make the answer very short. 0.92. What is the ratio of the Borrowers(per 1000 adults) in Small states in 2010 to that in 2011?
Keep it short and to the point. 0.63. What is the ratio of the Borrowers(per 1000 adults) of Brunei Darussalam in 2010 to that in 2011?
Your response must be concise. 1.04. What is the ratio of the Borrowers(per 1000 adults) of Guinea in 2010 to that in 2011?
Your answer should be compact. 0.8. What is the ratio of the Borrowers(per 1000 adults) in Middle East & North Africa (developing only) in 2010 to that in 2012?
Offer a terse response. 1.01. What is the ratio of the Borrowers(per 1000 adults) in Small states in 2010 to that in 2012?
Your answer should be very brief. 0.63. What is the ratio of the Borrowers(per 1000 adults) of Brunei Darussalam in 2010 to that in 2012?
Make the answer very short. 0.96. What is the ratio of the Borrowers(per 1000 adults) of Guinea in 2010 to that in 2012?
Your response must be concise. 0.63. What is the ratio of the Borrowers(per 1000 adults) in Middle East & North Africa (developing only) in 2010 to that in 2013?
Your answer should be compact. 0.76. What is the ratio of the Borrowers(per 1000 adults) in Small states in 2010 to that in 2013?
Provide a succinct answer. 0.38. What is the ratio of the Borrowers(per 1000 adults) in Brunei Darussalam in 2010 to that in 2013?
Provide a short and direct response. 0.94. What is the ratio of the Borrowers(per 1000 adults) in Guinea in 2010 to that in 2013?
Offer a very short reply. 0.51. What is the ratio of the Borrowers(per 1000 adults) of Middle East & North Africa (developing only) in 2011 to that in 2012?
Give a very brief answer. 1.1. What is the ratio of the Borrowers(per 1000 adults) in Small states in 2011 to that in 2012?
Offer a terse response. 1. What is the ratio of the Borrowers(per 1000 adults) in Brunei Darussalam in 2011 to that in 2012?
Provide a short and direct response. 0.92. What is the ratio of the Borrowers(per 1000 adults) in Guinea in 2011 to that in 2012?
Provide a short and direct response. 0.79. What is the ratio of the Borrowers(per 1000 adults) of Middle East & North Africa (developing only) in 2011 to that in 2013?
Offer a terse response. 0.83. What is the ratio of the Borrowers(per 1000 adults) in Small states in 2011 to that in 2013?
Your answer should be compact. 0.6. What is the ratio of the Borrowers(per 1000 adults) in Brunei Darussalam in 2011 to that in 2013?
Your answer should be very brief. 0.9. What is the ratio of the Borrowers(per 1000 adults) in Guinea in 2011 to that in 2013?
Make the answer very short. 0.65. What is the ratio of the Borrowers(per 1000 adults) in Middle East & North Africa (developing only) in 2012 to that in 2013?
Your response must be concise. 0.76. What is the ratio of the Borrowers(per 1000 adults) of Small states in 2012 to that in 2013?
Provide a short and direct response. 0.6. What is the ratio of the Borrowers(per 1000 adults) of Brunei Darussalam in 2012 to that in 2013?
Provide a succinct answer. 0.97. What is the ratio of the Borrowers(per 1000 adults) of Guinea in 2012 to that in 2013?
Offer a very short reply. 0.82. What is the difference between the highest and the second highest Borrowers(per 1000 adults) in Middle East & North Africa (developing only)?
Ensure brevity in your answer.  10.79. What is the difference between the highest and the second highest Borrowers(per 1000 adults) in Small states?
Keep it short and to the point. 47.18. What is the difference between the highest and the second highest Borrowers(per 1000 adults) of Brunei Darussalam?
Offer a very short reply. 71.35. What is the difference between the highest and the second highest Borrowers(per 1000 adults) in Guinea?
Your response must be concise. 1.84. What is the difference between the highest and the lowest Borrowers(per 1000 adults) in Middle East & North Africa (developing only)?
Ensure brevity in your answer.  35.65. What is the difference between the highest and the lowest Borrowers(per 1000 adults) of Small states?
Provide a short and direct response. 73.06. What is the difference between the highest and the lowest Borrowers(per 1000 adults) of Brunei Darussalam?
Offer a very short reply. 177.78. What is the difference between the highest and the lowest Borrowers(per 1000 adults) in Guinea?
Offer a very short reply. 6.51. 